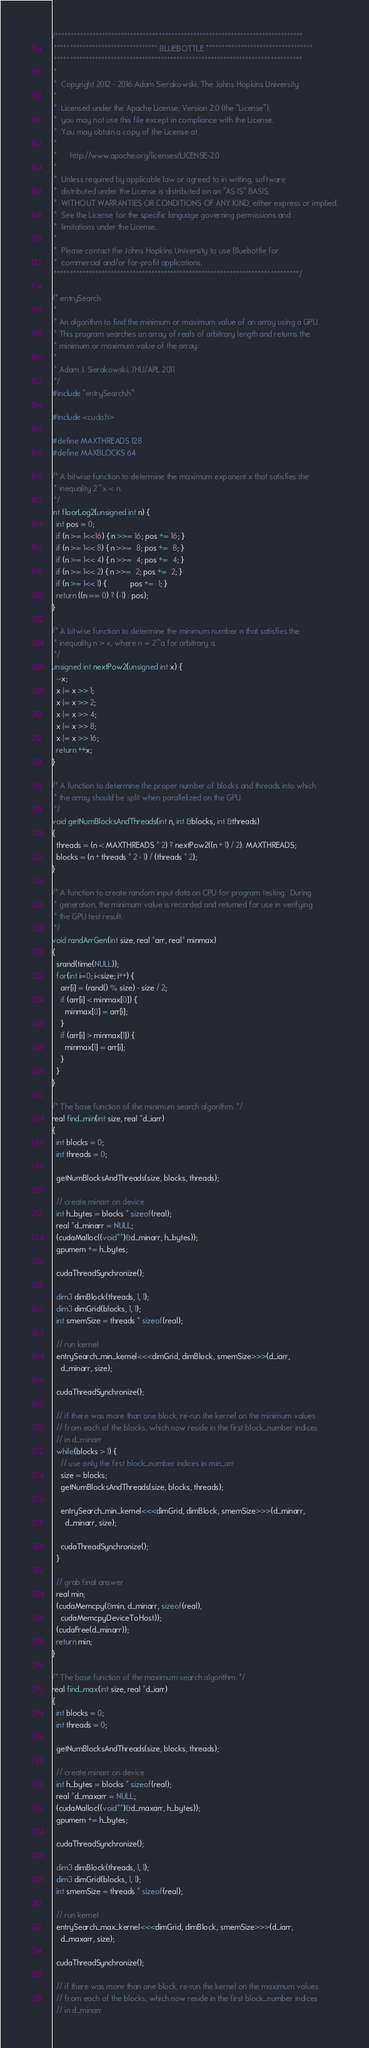<code> <loc_0><loc_0><loc_500><loc_500><_Cuda_>/*******************************************************************************
 ********************************* BLUEBOTTLE **********************************
 *******************************************************************************
 *
 *  Copyright 2012 - 2016 Adam Sierakowski, The Johns Hopkins University
 *
 *  Licensed under the Apache License, Version 2.0 (the "License");
 *  you may not use this file except in compliance with the License.
 *  You may obtain a copy of the License at
 *
 *      http://www.apache.org/licenses/LICENSE-2.0
 *
 *  Unless required by applicable law or agreed to in writing, software
 *  distributed under the License is distributed on an "AS IS" BASIS,
 *  WITHOUT WARRANTIES OR CONDITIONS OF ANY KIND, either express or implied.
 *  See the License for the specific language governing permissions and
 *  limitations under the License.
 *
 *  Please contact the Johns Hopkins University to use Bluebottle for
 *  commercial and/or for-profit applications.
 ******************************************************************************/

/* entrySearch
 *
 * An algorithm to find the minimum or maximum value of an array using a GPU.
 * This program searches an array of reals of arbitrary length and returns the
 * minimum or maximum value of the array.
 *
 * Adam J. Sierakowski, JHU/APL 2011
 */
#include "entrySearch.h"

#include <cuda.h>

#define MAXTHREADS 128
#define MAXBLOCKS 64

/* A bitwise function to determine the maximum exponent x that satisfies the
 * inequality 2^x < n.
 */
int floorLog2(unsigned int n) {
  int pos = 0;
  if (n >= 1<<16) { n >>= 16; pos += 16; }
  if (n >= 1<< 8) { n >>=  8; pos +=  8; }
  if (n >= 1<< 4) { n >>=  4; pos +=  4; }
  if (n >= 1<< 2) { n >>=  2; pos +=  2; }
  if (n >= 1<< 1) {           pos +=  1; }
  return ((n == 0) ? (-1) : pos);
}

/* A bitwise function to determine the minimum number n that satisfies the
 * inequality n > x, where n = 2^a for arbitrary a.
 */
unsigned int nextPow2(unsigned int x) {
  --x;
  x |= x >> 1;
  x |= x >> 2;
  x |= x >> 4;
  x |= x >> 8;
  x |= x >> 16;
  return ++x;
}

/* A function to determine the proper number of blocks and threads into which
 * the array should be split when parallelized on the GPU.
 */
void getNumBlocksAndThreads(int n, int &blocks, int &threads)
{
  threads = (n < MAXTHREADS * 2) ? nextPow2((n + 1) / 2): MAXTHREADS;
  blocks = (n + threads * 2 - 1) / (threads * 2);
}

/* A function to create random input data on CPU for program testing.  During
 * generation, the minimum value is recorded and returned for use in verifying
 * the GPU test result.
 */
void randArrGen(int size, real *arr, real* minmax)
{
  srand(time(NULL));
  for(int i=0; i<size; i++) {
    arr[i] = (rand() % size) - size / 2;
    if (arr[i] < minmax[0]) {
      minmax[0] = arr[i];
    }
    if (arr[i] > minmax[1]) {
      minmax[1] = arr[i];
    }
  }
}

/* The base function of the minimum search algorithm. */
real find_min(int size, real *d_iarr)
{
  int blocks = 0;
  int threads = 0;

  getNumBlocksAndThreads(size, blocks, threads);

  // create minarr on device
  int h_bytes = blocks * sizeof(real);
  real *d_minarr = NULL;
  (cudaMalloc((void**)&d_minarr, h_bytes));
  gpumem += h_bytes;

  cudaThreadSynchronize();

  dim3 dimBlock(threads, 1, 1);
  dim3 dimGrid(blocks, 1, 1);
  int smemSize = threads * sizeof(real);

  // run kernel
  entrySearch_min_kernel<<<dimGrid, dimBlock, smemSize>>>(d_iarr,
    d_minarr, size);

  cudaThreadSynchronize();

  // if there was more than one block, re-run the kernel on the minimum values 
  // from each of the blocks, which now reside in the first block_number indices
  // in d_minarr
  while(blocks > 1) {
    // use only the first block_number indices in min_arr
    size = blocks;
    getNumBlocksAndThreads(size, blocks, threads);

    entrySearch_min_kernel<<<dimGrid, dimBlock, smemSize>>>(d_minarr,
      d_minarr, size);

    cudaThreadSynchronize();
  }

  // grab final answer
  real min;
  (cudaMemcpy(&min, d_minarr, sizeof(real),
    cudaMemcpyDeviceToHost));
  (cudaFree(d_minarr));
  return min;
}

/* The base function of the maximum search algorithm. */
real find_max(int size, real *d_iarr)
{
  int blocks = 0;
  int threads = 0;

  getNumBlocksAndThreads(size, blocks, threads);

  // create minarr on device
  int h_bytes = blocks * sizeof(real);
  real *d_maxarr = NULL;
  (cudaMalloc((void**)&d_maxarr, h_bytes));
  gpumem += h_bytes;

  cudaThreadSynchronize();

  dim3 dimBlock(threads, 1, 1);
  dim3 dimGrid(blocks, 1, 1);
  int smemSize = threads * sizeof(real);

  // run kernel
  entrySearch_max_kernel<<<dimGrid, dimBlock, smemSize>>>(d_iarr,
    d_maxarr, size);

  cudaThreadSynchronize();

  // if there was more than one block, re-run the kernel on the maximum values 
  // from each of the blocks, which now reside in the first block_number indices
  // in d_minarr</code> 